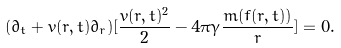Convert formula to latex. <formula><loc_0><loc_0><loc_500><loc_500>( \partial _ { t } + v ( r , t ) \partial _ { r } ) [ \frac { v ( r , t ) ^ { 2 } } { 2 } - 4 \pi \gamma \frac { m ( f ( r , t ) ) } { r } ] = 0 .</formula> 